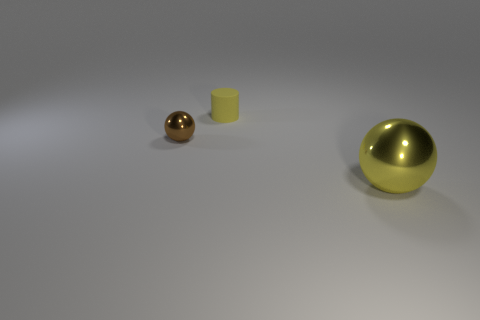Add 2 large blue cylinders. How many objects exist? 5 Subtract all spheres. How many objects are left? 1 Subtract all yellow cubes. How many yellow balls are left? 1 Subtract all yellow matte objects. Subtract all big metal balls. How many objects are left? 1 Add 2 big yellow shiny things. How many big yellow shiny things are left? 3 Add 3 big metallic things. How many big metallic things exist? 4 Subtract 0 purple balls. How many objects are left? 3 Subtract 2 balls. How many balls are left? 0 Subtract all brown spheres. Subtract all gray cubes. How many spheres are left? 1 